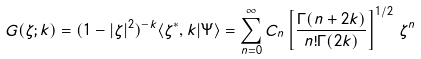Convert formula to latex. <formula><loc_0><loc_0><loc_500><loc_500>G ( \zeta ; k ) = ( 1 - | \zeta | ^ { 2 } ) ^ { - k } \langle \zeta ^ { \ast } , k | \Psi \rangle = \sum _ { n = 0 } ^ { \infty } C _ { n } \left [ \frac { \Gamma ( n + 2 k ) } { n ! \Gamma ( 2 k ) } \right ] ^ { 1 / 2 } \, \zeta ^ { n }</formula> 